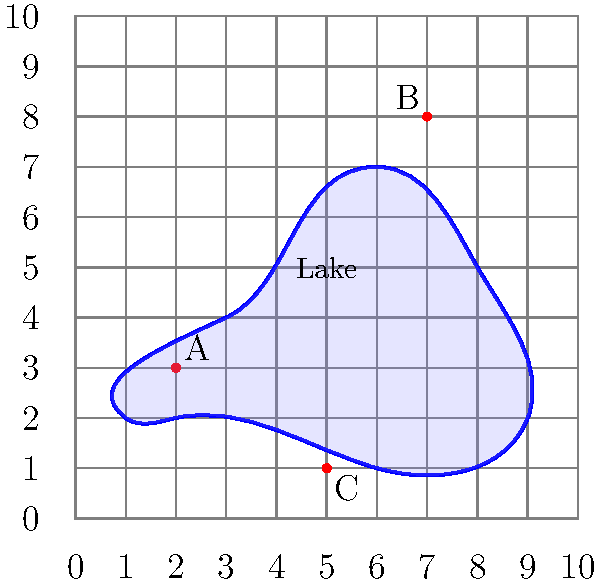You've hand-drawn a map of your favorite fishing lake on a simple 10x10 grid. You've marked three prime fishing spots: A (2,3), B (7,8), and C (5,1). If you're in your boat at spot A and want to move to spot C, how many units east and how many units south must you travel? To solve this problem, we need to follow these steps:

1. Identify the coordinates of the starting point (A) and the endpoint (C):
   - Spot A is at (2,3)
   - Spot C is at (5,1)

2. Calculate the change in the east-west direction (x-axis):
   - Change in x = x-coordinate of C - x-coordinate of A
   - Change in x = 5 - 2 = 3 units east

3. Calculate the change in the north-south direction (y-axis):
   - Change in y = y-coordinate of C - y-coordinate of A
   - Change in y = 1 - 3 = -2 units (negative means moving south)

4. Express the movement in terms of east and south:
   - 3 units east
   - 2 units south

Therefore, to move from spot A to spot C, you must travel 3 units east and 2 units south.
Answer: 3 units east, 2 units south 